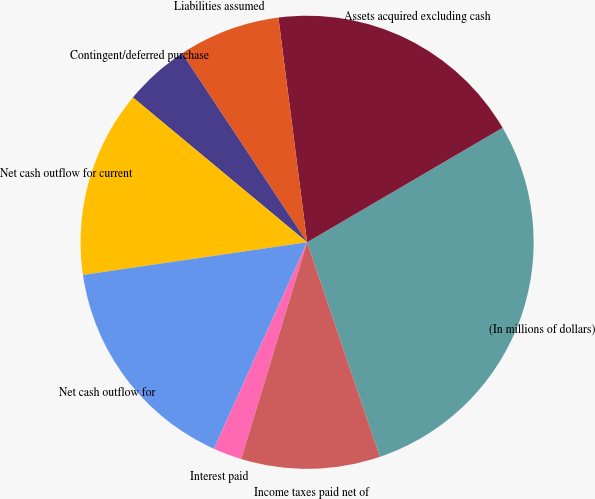<chart> <loc_0><loc_0><loc_500><loc_500><pie_chart><fcel>(In millions of dollars)<fcel>Assets acquired excluding cash<fcel>Liabilities assumed<fcel>Contingent/deferred purchase<fcel>Net cash outflow for current<fcel>Net cash outflow for<fcel>Interest paid<fcel>Income taxes paid net of<nl><fcel>28.23%<fcel>18.59%<fcel>7.28%<fcel>4.66%<fcel>13.34%<fcel>15.95%<fcel>2.05%<fcel>9.9%<nl></chart> 